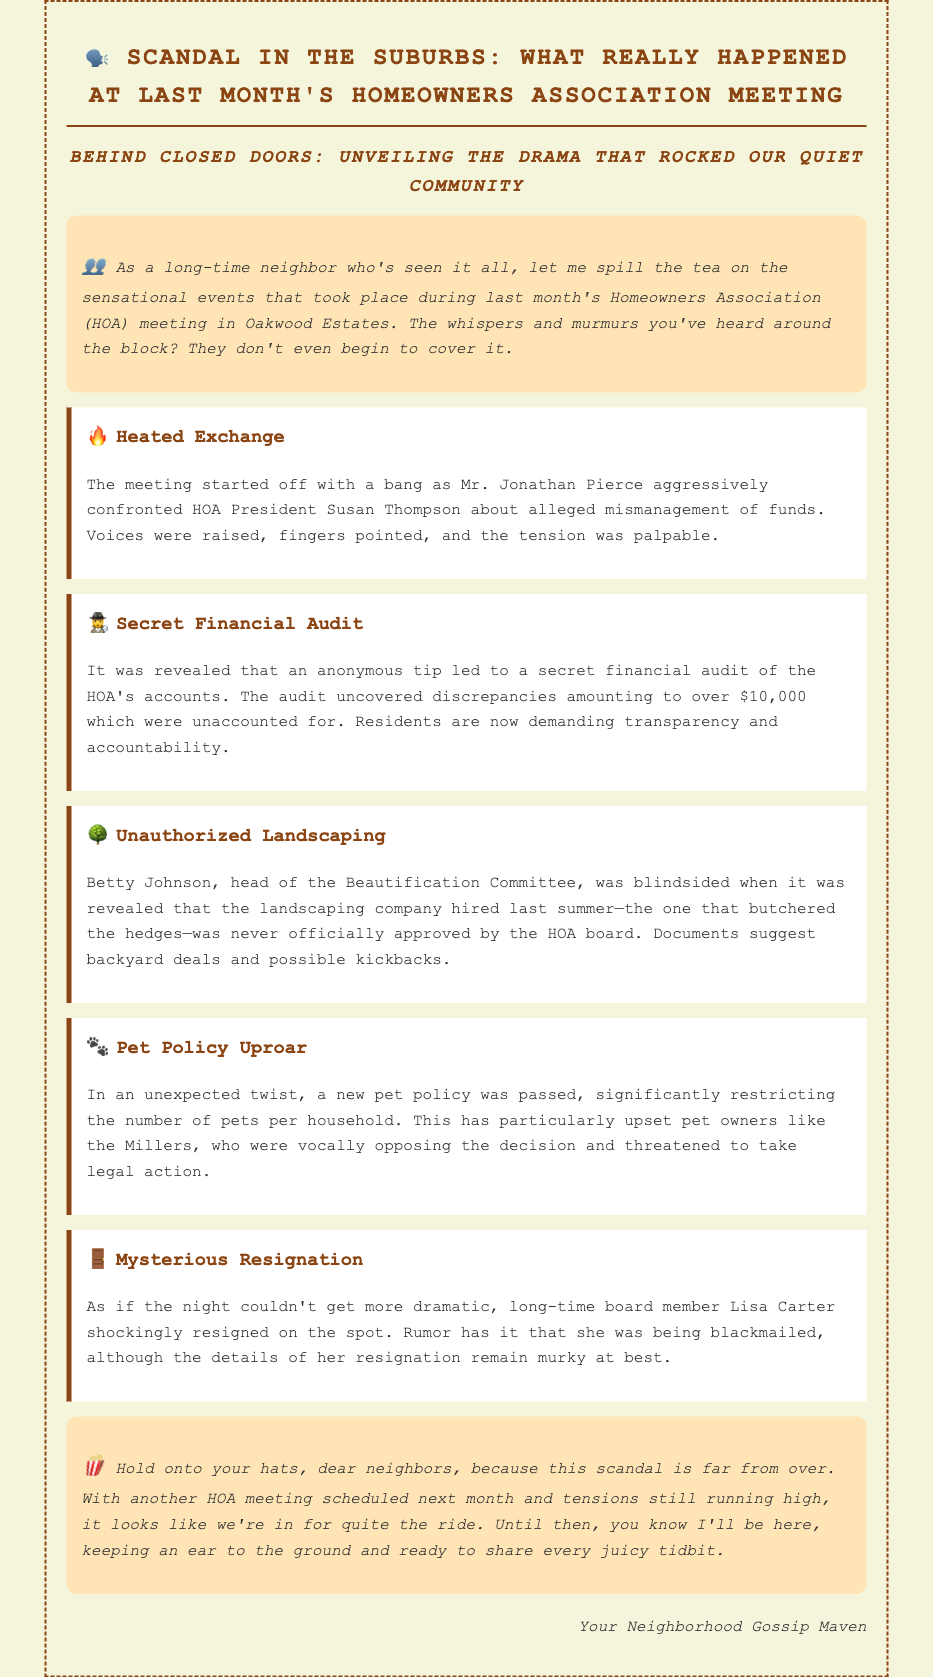What was the main issue raised by Jonathan Pierce? Jonathan Pierce confronted HOA President Susan Thompson about alleged mismanagement of funds.
Answer: Mismanagement of funds How much money was found to be unaccounted for in the audit? The audit uncovered discrepancies amounting to over $10,000 which were unaccounted for.
Answer: Over $10,000 Who was blindsided by the revelation regarding landscaping? Betty Johnson, head of the Beautification Committee, was blindsided when it was revealed.
Answer: Betty Johnson What new policy was passed that upset pet owners? A new pet policy was passed, significantly restricting the number of pets per household.
Answer: Pets per household restriction Who resigned during the meeting, sparking rumors of blackmail? Long-time board member Lisa Carter shockingly resigned on the spot.
Answer: Lisa Carter Why is the upcoming HOA meeting anticipated? There are unresolved tensions from the previous meeting, and residents are seeking answers.
Answer: Unresolved tensions What demographic of residents was particularly vocal about the new pet policy? Pet owners like the Millers were vocally opposing the decision.
Answer: Pet owners What prompted the secret financial audit? An anonymous tip led to a secret financial audit of the HOA's accounts.
Answer: Anonymous tip 